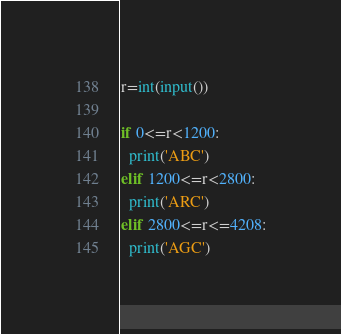Convert code to text. <code><loc_0><loc_0><loc_500><loc_500><_Python_>r=int(input())

if 0<=r<1200:
  print('ABC')
elif 1200<=r<2800:
  print('ARC')
elif 2800<=r<=4208:
  print('AGC')</code> 